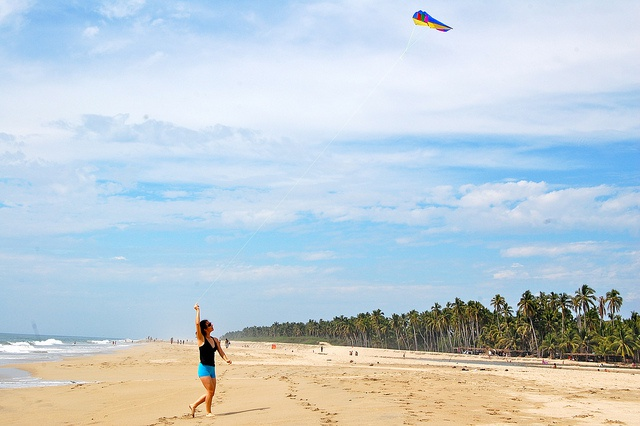Describe the objects in this image and their specific colors. I can see people in lightblue, black, brown, and tan tones, kite in lightblue, blue, gold, orange, and white tones, people in lightblue, gray, and black tones, people in lightblue, brown, violet, and lightpink tones, and people in lightblue, maroon, tan, ivory, and gray tones in this image. 